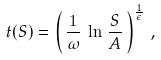<formula> <loc_0><loc_0><loc_500><loc_500>t ( S ) = \left ( \, \frac { 1 } { \omega } \, \ln \, \frac { S } { A } \, \right ) ^ { \frac { 1 } { \epsilon } } \, ,</formula> 